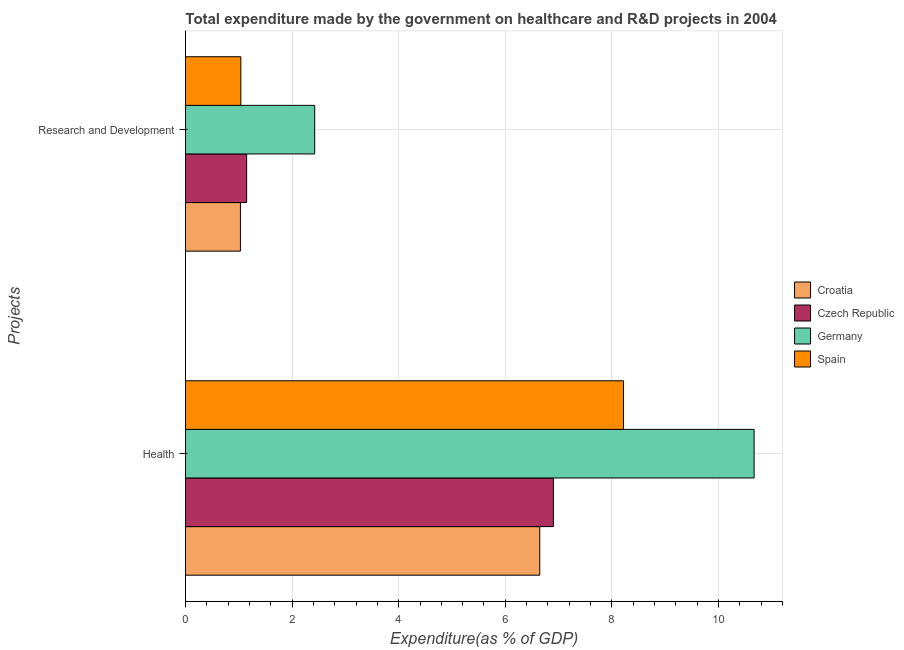How many different coloured bars are there?
Make the answer very short. 4. How many groups of bars are there?
Keep it short and to the point. 2. Are the number of bars per tick equal to the number of legend labels?
Offer a very short reply. Yes. How many bars are there on the 1st tick from the top?
Provide a short and direct response. 4. What is the label of the 2nd group of bars from the top?
Your response must be concise. Health. What is the expenditure in healthcare in Croatia?
Provide a succinct answer. 6.65. Across all countries, what is the maximum expenditure in healthcare?
Offer a terse response. 10.67. Across all countries, what is the minimum expenditure in r&d?
Your response must be concise. 1.03. In which country was the expenditure in healthcare maximum?
Offer a very short reply. Germany. In which country was the expenditure in r&d minimum?
Give a very brief answer. Croatia. What is the total expenditure in r&d in the graph?
Offer a terse response. 5.64. What is the difference between the expenditure in healthcare in Czech Republic and that in Croatia?
Keep it short and to the point. 0.26. What is the difference between the expenditure in r&d in Croatia and the expenditure in healthcare in Spain?
Your answer should be compact. -7.19. What is the average expenditure in healthcare per country?
Your response must be concise. 8.11. What is the difference between the expenditure in r&d and expenditure in healthcare in Czech Republic?
Keep it short and to the point. -5.76. What is the ratio of the expenditure in healthcare in Czech Republic to that in Germany?
Ensure brevity in your answer.  0.65. In how many countries, is the expenditure in healthcare greater than the average expenditure in healthcare taken over all countries?
Make the answer very short. 2. What does the 2nd bar from the top in Health represents?
Your answer should be compact. Germany. What does the 3rd bar from the bottom in Research and Development represents?
Your response must be concise. Germany. Are all the bars in the graph horizontal?
Make the answer very short. Yes. Does the graph contain any zero values?
Provide a short and direct response. No. What is the title of the graph?
Provide a short and direct response. Total expenditure made by the government on healthcare and R&D projects in 2004. What is the label or title of the X-axis?
Ensure brevity in your answer.  Expenditure(as % of GDP). What is the label or title of the Y-axis?
Give a very brief answer. Projects. What is the Expenditure(as % of GDP) in Croatia in Health?
Your response must be concise. 6.65. What is the Expenditure(as % of GDP) of Czech Republic in Health?
Make the answer very short. 6.9. What is the Expenditure(as % of GDP) of Germany in Health?
Keep it short and to the point. 10.67. What is the Expenditure(as % of GDP) of Spain in Health?
Your answer should be very brief. 8.22. What is the Expenditure(as % of GDP) of Croatia in Research and Development?
Provide a short and direct response. 1.03. What is the Expenditure(as % of GDP) in Czech Republic in Research and Development?
Your answer should be compact. 1.15. What is the Expenditure(as % of GDP) in Germany in Research and Development?
Ensure brevity in your answer.  2.42. What is the Expenditure(as % of GDP) in Spain in Research and Development?
Offer a very short reply. 1.04. Across all Projects, what is the maximum Expenditure(as % of GDP) of Croatia?
Your answer should be very brief. 6.65. Across all Projects, what is the maximum Expenditure(as % of GDP) of Czech Republic?
Keep it short and to the point. 6.9. Across all Projects, what is the maximum Expenditure(as % of GDP) in Germany?
Provide a short and direct response. 10.67. Across all Projects, what is the maximum Expenditure(as % of GDP) in Spain?
Provide a short and direct response. 8.22. Across all Projects, what is the minimum Expenditure(as % of GDP) of Croatia?
Ensure brevity in your answer.  1.03. Across all Projects, what is the minimum Expenditure(as % of GDP) in Czech Republic?
Ensure brevity in your answer.  1.15. Across all Projects, what is the minimum Expenditure(as % of GDP) of Germany?
Your response must be concise. 2.42. Across all Projects, what is the minimum Expenditure(as % of GDP) of Spain?
Give a very brief answer. 1.04. What is the total Expenditure(as % of GDP) in Croatia in the graph?
Your answer should be very brief. 7.68. What is the total Expenditure(as % of GDP) in Czech Republic in the graph?
Ensure brevity in your answer.  8.05. What is the total Expenditure(as % of GDP) in Germany in the graph?
Offer a very short reply. 13.09. What is the total Expenditure(as % of GDP) in Spain in the graph?
Offer a terse response. 9.26. What is the difference between the Expenditure(as % of GDP) in Croatia in Health and that in Research and Development?
Offer a very short reply. 5.62. What is the difference between the Expenditure(as % of GDP) in Czech Republic in Health and that in Research and Development?
Make the answer very short. 5.76. What is the difference between the Expenditure(as % of GDP) in Germany in Health and that in Research and Development?
Ensure brevity in your answer.  8.24. What is the difference between the Expenditure(as % of GDP) in Spain in Health and that in Research and Development?
Your answer should be compact. 7.18. What is the difference between the Expenditure(as % of GDP) in Croatia in Health and the Expenditure(as % of GDP) in Czech Republic in Research and Development?
Your answer should be very brief. 5.5. What is the difference between the Expenditure(as % of GDP) of Croatia in Health and the Expenditure(as % of GDP) of Germany in Research and Development?
Keep it short and to the point. 4.22. What is the difference between the Expenditure(as % of GDP) of Croatia in Health and the Expenditure(as % of GDP) of Spain in Research and Development?
Ensure brevity in your answer.  5.61. What is the difference between the Expenditure(as % of GDP) of Czech Republic in Health and the Expenditure(as % of GDP) of Germany in Research and Development?
Your answer should be compact. 4.48. What is the difference between the Expenditure(as % of GDP) in Czech Republic in Health and the Expenditure(as % of GDP) in Spain in Research and Development?
Provide a short and direct response. 5.87. What is the difference between the Expenditure(as % of GDP) of Germany in Health and the Expenditure(as % of GDP) of Spain in Research and Development?
Your answer should be very brief. 9.63. What is the average Expenditure(as % of GDP) in Croatia per Projects?
Give a very brief answer. 3.84. What is the average Expenditure(as % of GDP) in Czech Republic per Projects?
Ensure brevity in your answer.  4.03. What is the average Expenditure(as % of GDP) in Germany per Projects?
Keep it short and to the point. 6.55. What is the average Expenditure(as % of GDP) in Spain per Projects?
Keep it short and to the point. 4.63. What is the difference between the Expenditure(as % of GDP) in Croatia and Expenditure(as % of GDP) in Czech Republic in Health?
Keep it short and to the point. -0.26. What is the difference between the Expenditure(as % of GDP) of Croatia and Expenditure(as % of GDP) of Germany in Health?
Your answer should be very brief. -4.02. What is the difference between the Expenditure(as % of GDP) in Croatia and Expenditure(as % of GDP) in Spain in Health?
Ensure brevity in your answer.  -1.57. What is the difference between the Expenditure(as % of GDP) of Czech Republic and Expenditure(as % of GDP) of Germany in Health?
Give a very brief answer. -3.77. What is the difference between the Expenditure(as % of GDP) in Czech Republic and Expenditure(as % of GDP) in Spain in Health?
Make the answer very short. -1.32. What is the difference between the Expenditure(as % of GDP) of Germany and Expenditure(as % of GDP) of Spain in Health?
Your answer should be very brief. 2.45. What is the difference between the Expenditure(as % of GDP) in Croatia and Expenditure(as % of GDP) in Czech Republic in Research and Development?
Provide a succinct answer. -0.12. What is the difference between the Expenditure(as % of GDP) of Croatia and Expenditure(as % of GDP) of Germany in Research and Development?
Offer a very short reply. -1.39. What is the difference between the Expenditure(as % of GDP) in Croatia and Expenditure(as % of GDP) in Spain in Research and Development?
Your answer should be compact. -0.01. What is the difference between the Expenditure(as % of GDP) of Czech Republic and Expenditure(as % of GDP) of Germany in Research and Development?
Offer a very short reply. -1.28. What is the difference between the Expenditure(as % of GDP) of Czech Republic and Expenditure(as % of GDP) of Spain in Research and Development?
Offer a very short reply. 0.11. What is the difference between the Expenditure(as % of GDP) of Germany and Expenditure(as % of GDP) of Spain in Research and Development?
Make the answer very short. 1.39. What is the ratio of the Expenditure(as % of GDP) in Croatia in Health to that in Research and Development?
Provide a succinct answer. 6.45. What is the ratio of the Expenditure(as % of GDP) of Czech Republic in Health to that in Research and Development?
Your response must be concise. 6.02. What is the ratio of the Expenditure(as % of GDP) of Germany in Health to that in Research and Development?
Your response must be concise. 4.4. What is the ratio of the Expenditure(as % of GDP) of Spain in Health to that in Research and Development?
Keep it short and to the point. 7.91. What is the difference between the highest and the second highest Expenditure(as % of GDP) in Croatia?
Your response must be concise. 5.62. What is the difference between the highest and the second highest Expenditure(as % of GDP) of Czech Republic?
Your response must be concise. 5.76. What is the difference between the highest and the second highest Expenditure(as % of GDP) in Germany?
Your answer should be very brief. 8.24. What is the difference between the highest and the second highest Expenditure(as % of GDP) in Spain?
Offer a terse response. 7.18. What is the difference between the highest and the lowest Expenditure(as % of GDP) of Croatia?
Your answer should be compact. 5.62. What is the difference between the highest and the lowest Expenditure(as % of GDP) in Czech Republic?
Keep it short and to the point. 5.76. What is the difference between the highest and the lowest Expenditure(as % of GDP) in Germany?
Keep it short and to the point. 8.24. What is the difference between the highest and the lowest Expenditure(as % of GDP) in Spain?
Keep it short and to the point. 7.18. 